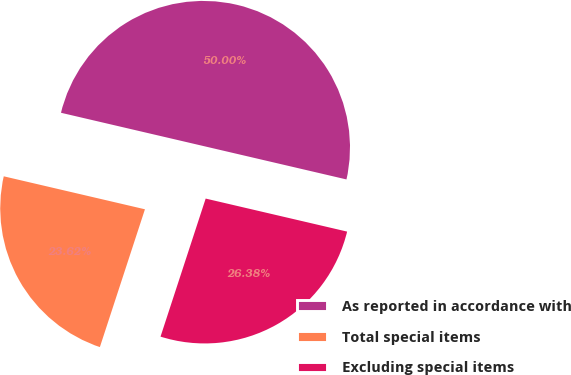<chart> <loc_0><loc_0><loc_500><loc_500><pie_chart><fcel>As reported in accordance with<fcel>Total special items<fcel>Excluding special items<nl><fcel>50.0%<fcel>23.62%<fcel>26.38%<nl></chart> 